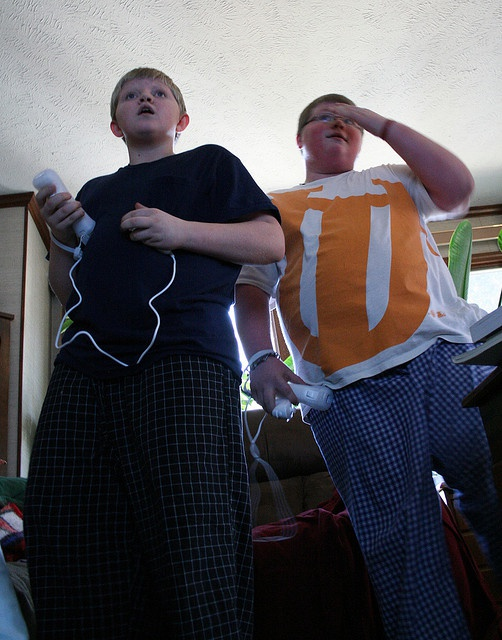Describe the objects in this image and their specific colors. I can see people in darkgray, black, gray, and navy tones, people in darkgray, black, maroon, navy, and brown tones, couch in darkgray, black, purple, and gray tones, remote in darkgray, gray, and black tones, and remote in darkgray, gray, darkblue, and navy tones in this image. 